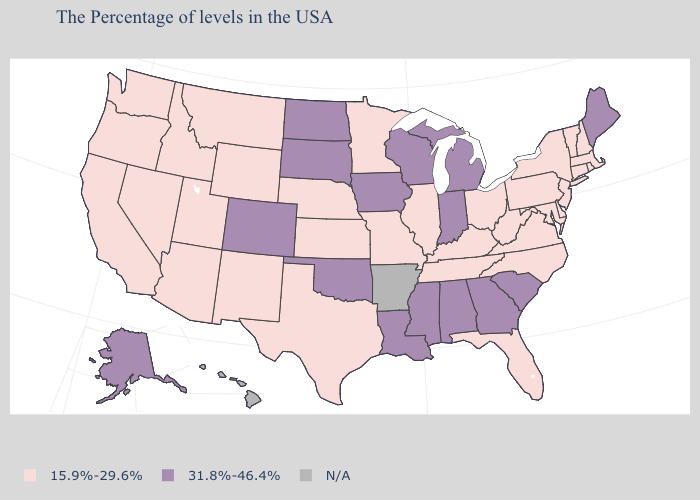Among the states that border Utah , does Wyoming have the highest value?
Answer briefly. No. How many symbols are there in the legend?
Quick response, please. 3. Among the states that border Tennessee , does Virginia have the lowest value?
Give a very brief answer. Yes. What is the value of Delaware?
Give a very brief answer. 15.9%-29.6%. What is the lowest value in the South?
Give a very brief answer. 15.9%-29.6%. Name the states that have a value in the range 15.9%-29.6%?
Keep it brief. Massachusetts, Rhode Island, New Hampshire, Vermont, Connecticut, New York, New Jersey, Delaware, Maryland, Pennsylvania, Virginia, North Carolina, West Virginia, Ohio, Florida, Kentucky, Tennessee, Illinois, Missouri, Minnesota, Kansas, Nebraska, Texas, Wyoming, New Mexico, Utah, Montana, Arizona, Idaho, Nevada, California, Washington, Oregon. Name the states that have a value in the range N/A?
Keep it brief. Arkansas, Hawaii. What is the highest value in the USA?
Short answer required. 31.8%-46.4%. Does Colorado have the highest value in the USA?
Be succinct. Yes. What is the value of New Mexico?
Concise answer only. 15.9%-29.6%. Among the states that border Oklahoma , does Colorado have the lowest value?
Concise answer only. No. What is the value of South Dakota?
Write a very short answer. 31.8%-46.4%. What is the lowest value in states that border Rhode Island?
Write a very short answer. 15.9%-29.6%. Among the states that border Georgia , does Tennessee have the lowest value?
Quick response, please. Yes. 